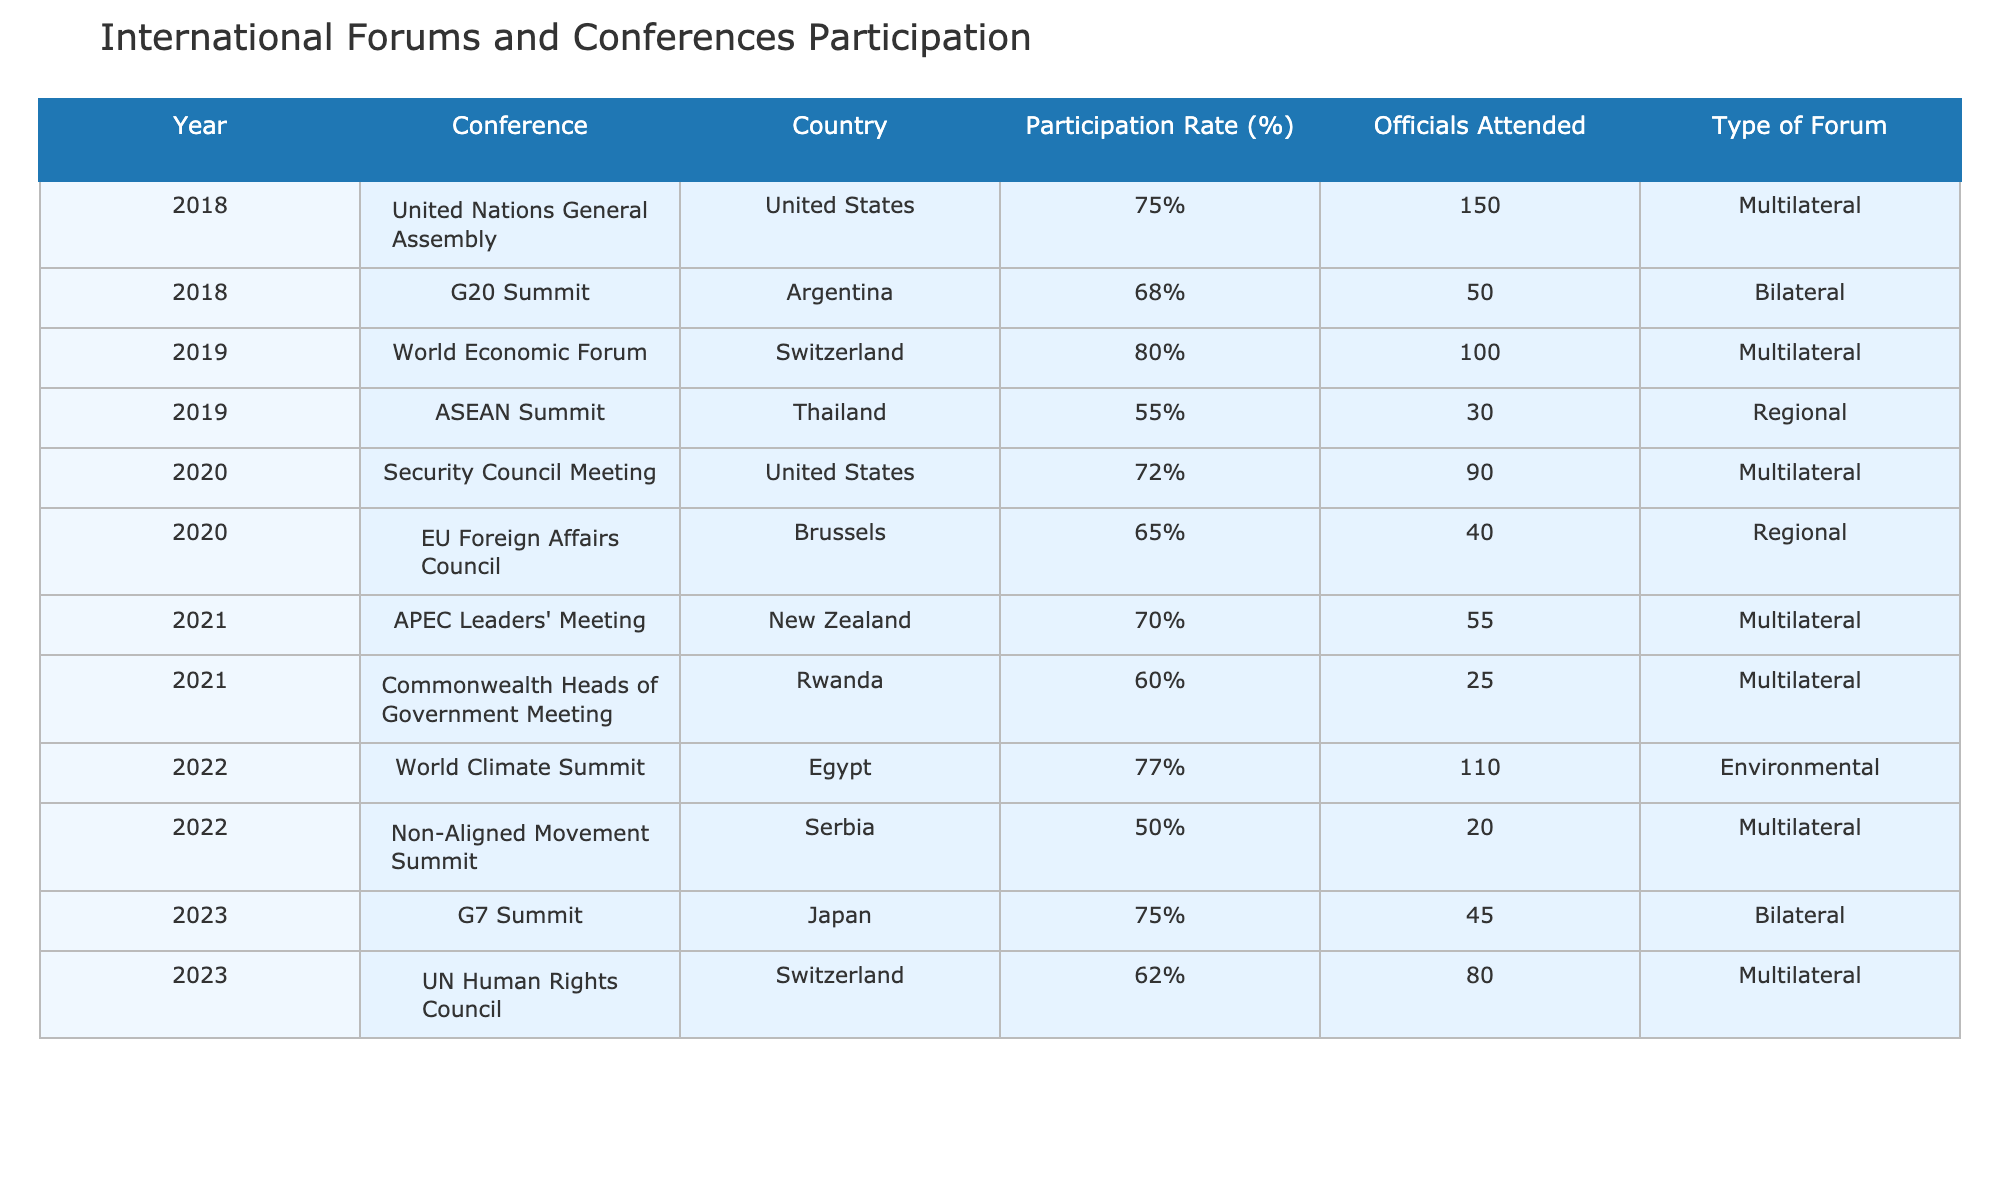What was the participation rate of the G20 Summit in 2018? The table indicates that the participation rate for the G20 Summit held in Argentina in 2018 was 68%.
Answer: 68% Which year had the highest participation rate? The World Economic Forum in 2019 had the highest participation rate at 80%.
Answer: 2019 How many officials attended the United Nations General Assembly in 2018? The table shows that 150 officials attended the United Nations General Assembly in 2018.
Answer: 150 What is the average participation rate for the years listed in the table? To find the average, we sum the participation rates: 75 + 68 + 80 + 55 + 72 + 65 + 70 + 60 + 77 + 50 + 75 + 62 =  70.5. There are 12 years, thus the average participation rate is 70.5%.
Answer: 70.5% Did more officials attend the World Climate Summit in 2022 than the ASEAN Summit in 2019? The table indicates that 110 officials attended the World Climate Summit in 2022, while only 30 attended the ASEAN Summit in 2019. Since 110 is greater than 30, the answer is yes.
Answer: Yes Which type of forum had the lowest participation rate, and what was the rate? The Non-Aligned Movement Summit in 2022 had the lowest participation rate at 50%.
Answer: Non-Aligned Movement Summit, 50% How many more officials attended the Security Council Meeting in 2020 compared to the EU Foreign Affairs Council that same year? The Security Council Meeting had 90 officials while the EU Foreign Affairs Council had 40 officials. The difference is 90 - 40 = 50.
Answer: 50 Which country hosted the highest number of participants in terms of percentage in 2022? The World Climate Summit in Egypt had the highest percentage of participants at 77% in 2022.
Answer: Egypt, 77% Was the participation rate for the G7 Summit in 2023 lower than that of the United Nations General Assembly in 2018? The G7 Summit had a participation rate of 75%, while the United Nations General Assembly had 75% as well. Since 75% is not less than 75%, the answer is no.
Answer: No What is the total number of officials that attended the APEC Leaders' Meeting and the Commonwealth Heads of Government Meeting combined? The APEC Leaders' Meeting had 55 officials and the Commonwealth Heads of Government Meeting had 25 officials. Adding them gives 55 + 25 = 80 officials.
Answer: 80 